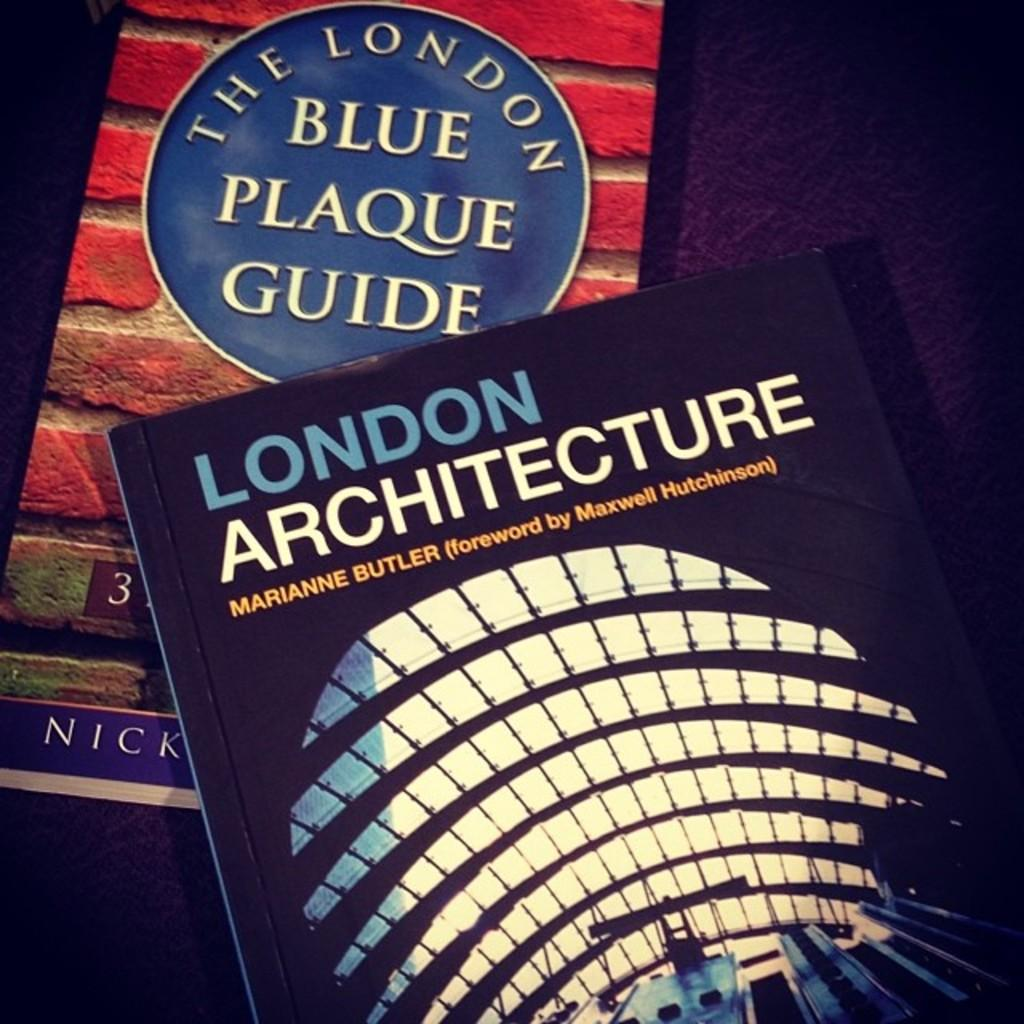How many books are visible in the image? There are two books in the image. Where are the books located? The books are placed on a table. What is the color of the background in the image? The background color appears to be dark violet. Can you see any giants in the image? No, there are no giants present in the image. What type of hook is used to hold the books in the image? There is no hook visible in the image; the books are simply placed on the table. 